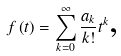<formula> <loc_0><loc_0><loc_500><loc_500>f \left ( t \right ) = \sum _ { k = 0 } ^ { \infty } \frac { a _ { k } } { k ! } t ^ { k } \text {,}</formula> 